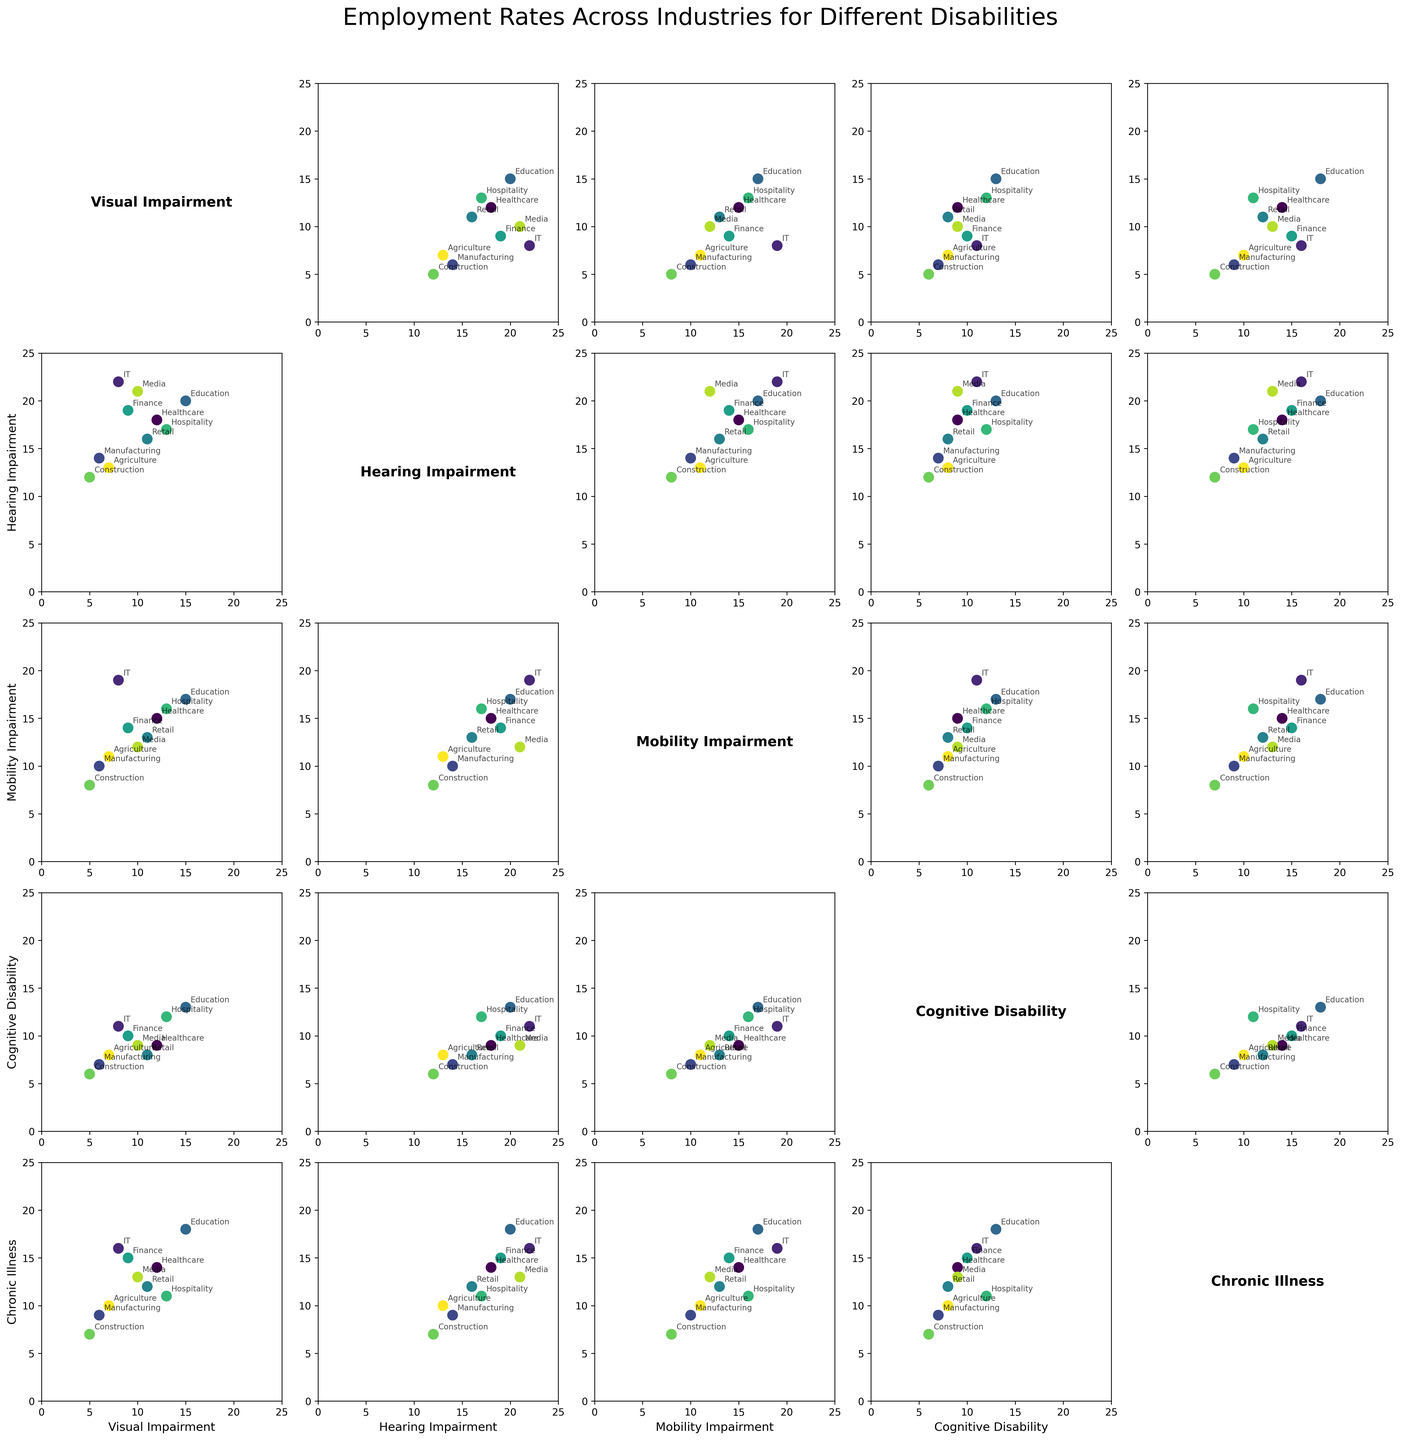Which industry shows the highest employment rate for individuals with Hearing Impairment? Look at the scatterplot for Hearing Impairment against all other disabilities and identify the industry with the highest y-axis value for Hearing Impairment. In this case, it is the IT industry.
Answer: IT Compare the employment rates for individuals with Cognitive Disability across the Education and Retail industries. Which is higher? Locate the points for the Education and Retail industries in the scatterplot matrix where the x-axis or y-axis represents Cognitive Disability. Compare the vertical positions of these points. The Education industry has a higher value.
Answer: Education Which disability shows a consistent employment rate across the Hospitality industry and Media industry? Find the scatterplots involving the Hospitality and Media industries. Identify the disability type that appears at similar x or y values across these plots for both Hospitality and Media. In this case, that disability is Chronic Illness.
Answer: Chronic Illness What is the average employment rate for individuals with Visual Impairment in the Healthcare and Education industries? Locate the points in the scatterplots where Visual Impairment is one of the axes. The rates for Healthcare and Education are 12 and 15, respectively. Calculate the average (12 + 15) / 2 = 13.5.
Answer: 13.5 Which disability has the widest range of employment rates across all industries? Look at each row or column in the scatterplot matrix to see the span (lowest to highest value) of points for each disability. Visual Impairment ranges from 5 to 15 across industries, covering the widest range of employment rates.
Answer: Visual Impairment How do employment rates for individuals with Mobility Impairment in Manufacturing compare with those in Construction? Identify the employment rates for Mobility Impairment in Manufacturing and Construction by finding their respective positions in the scatterplot matrix. Manufacturing has a rate of 10, while Construction has a rate of 8.
Answer: Manufacturing What's the average employment rate for individuals with Chronic Illness across all industries? Sum the employment rates of Chronic Illness for all industries (14 + 16 + 9 + 18 + 12 + 15 + 11 + 7 + 13 + 10) which equals 125. Then divide by the number of industries (125 / 10).
Answer: 12.5 Is there an industry with an equal rate of employment for individuals with Cognitive Disability and Visual Impairment? Look through the scatterplot matrix and find points where the values for Cognitive Disability and Visual Impairment are equal. No such point exists.
Answer: No 